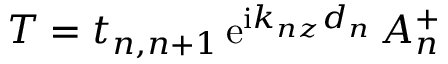<formula> <loc_0><loc_0><loc_500><loc_500>T = t _ { n , n + 1 } \, e ^ { i k _ { n z } d _ { n } } \, A _ { n } ^ { + }</formula> 